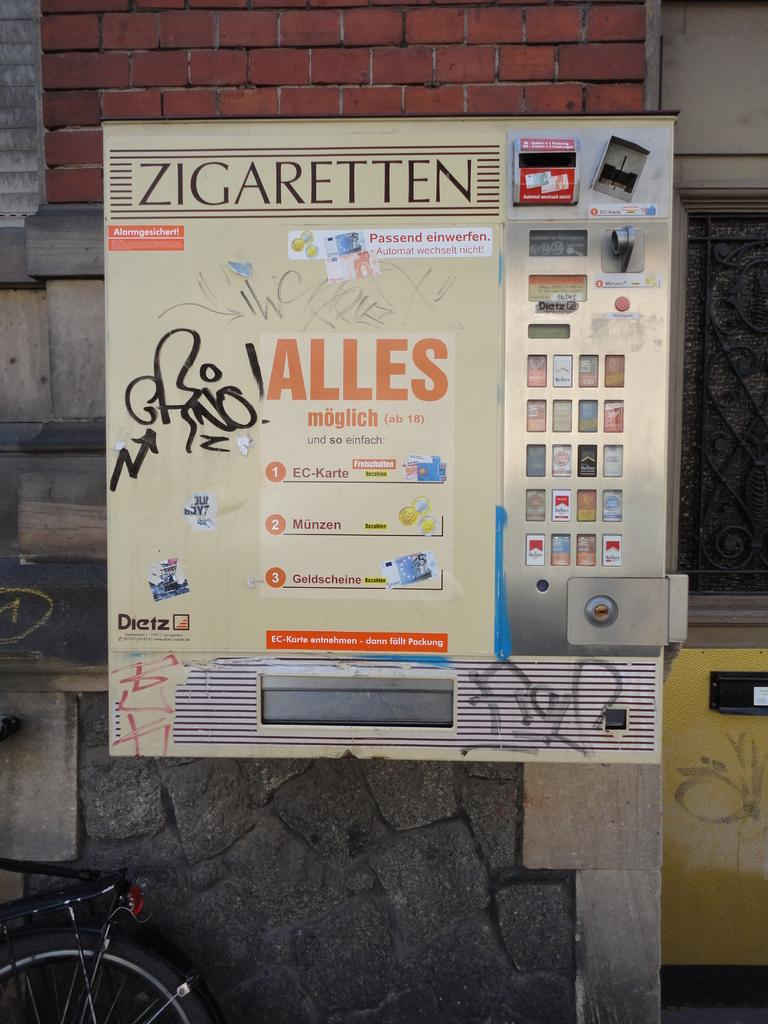Provide a one-sentence caption for the provided image. In Germany there is a vending machine for ZIGARETTEN or cigarettes. 